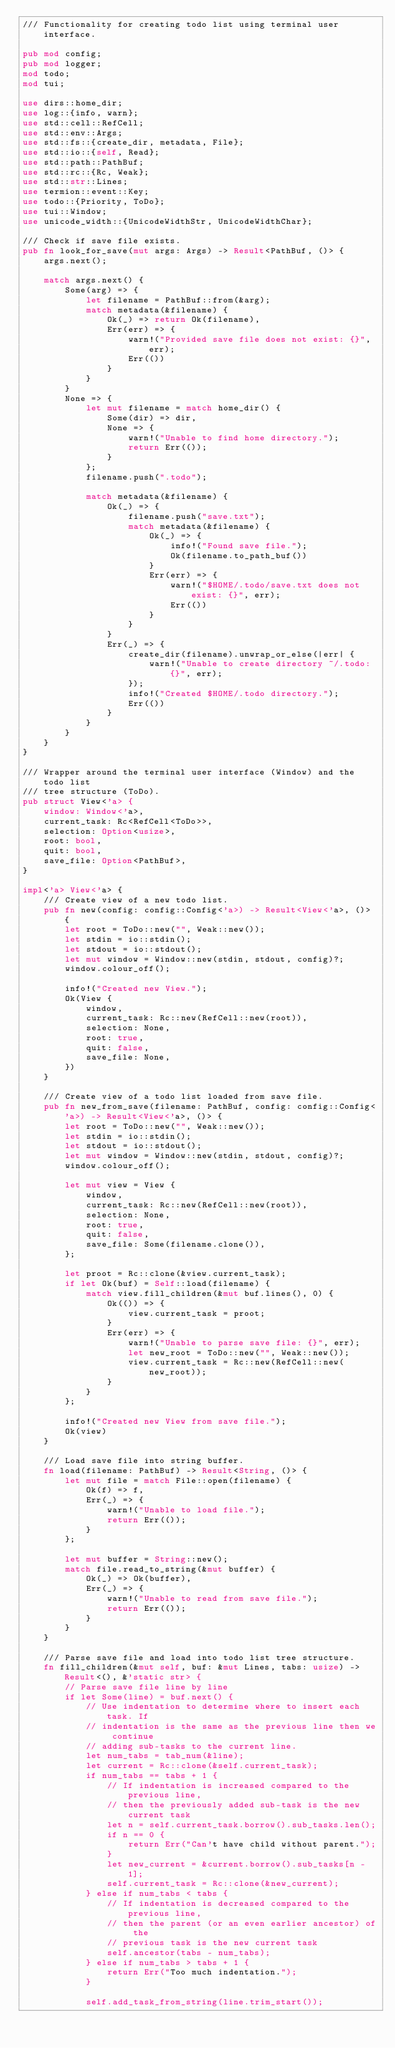Convert code to text. <code><loc_0><loc_0><loc_500><loc_500><_Rust_>/// Functionality for creating todo list using terminal user interface.

pub mod config;
pub mod logger;
mod todo;
mod tui;

use dirs::home_dir;
use log::{info, warn};
use std::cell::RefCell;
use std::env::Args;
use std::fs::{create_dir, metadata, File};
use std::io::{self, Read};
use std::path::PathBuf;
use std::rc::{Rc, Weak};
use std::str::Lines;
use termion::event::Key;
use todo::{Priority, ToDo};
use tui::Window;
use unicode_width::{UnicodeWidthStr, UnicodeWidthChar};

/// Check if save file exists.
pub fn look_for_save(mut args: Args) -> Result<PathBuf, ()> {
    args.next();

    match args.next() {
        Some(arg) => {
            let filename = PathBuf::from(&arg);
            match metadata(&filename) {
                Ok(_) => return Ok(filename),
                Err(err) => {
                    warn!("Provided save file does not exist: {}", err);
                    Err(())
                }
            }
        }
        None => {
            let mut filename = match home_dir() {
                Some(dir) => dir,
                None => {
                    warn!("Unable to find home directory.");
                    return Err(());
                }
            };
            filename.push(".todo");

            match metadata(&filename) {
                Ok(_) => {
                    filename.push("save.txt");
                    match metadata(&filename) {
                        Ok(_) => {
                            info!("Found save file.");
                            Ok(filename.to_path_buf())
                        }
                        Err(err) => {
                            warn!("$HOME/.todo/save.txt does not exist: {}", err);
                            Err(())
                        }
                    }
                }
                Err(_) => {
                    create_dir(filename).unwrap_or_else(|err| {
                        warn!("Unable to create directory ~/.todo: {}", err);
                    });
                    info!("Created $HOME/.todo directory.");
                    Err(())
                }
            }
        }
    }
}

/// Wrapper around the terminal user interface (Window) and the todo list
/// tree structure (ToDo).
pub struct View<'a> {
    window: Window<'a>,
    current_task: Rc<RefCell<ToDo>>,
    selection: Option<usize>,
    root: bool,
    quit: bool,
    save_file: Option<PathBuf>,
}

impl<'a> View<'a> {
    /// Create view of a new todo list.
    pub fn new(config: config::Config<'a>) -> Result<View<'a>, ()> {
        let root = ToDo::new("", Weak::new());
        let stdin = io::stdin();
        let stdout = io::stdout();
        let mut window = Window::new(stdin, stdout, config)?;
        window.colour_off();

        info!("Created new View.");
        Ok(View {
            window,
            current_task: Rc::new(RefCell::new(root)),
            selection: None,
            root: true,
            quit: false,
            save_file: None,
        })
    }

    /// Create view of a todo list loaded from save file.
    pub fn new_from_save(filename: PathBuf, config: config::Config<'a>) -> Result<View<'a>, ()> {
        let root = ToDo::new("", Weak::new());
        let stdin = io::stdin();
        let stdout = io::stdout();
        let mut window = Window::new(stdin, stdout, config)?;
        window.colour_off();

        let mut view = View {
            window,
            current_task: Rc::new(RefCell::new(root)),
            selection: None,
            root: true,
            quit: false,
            save_file: Some(filename.clone()),
        };

        let proot = Rc::clone(&view.current_task);
        if let Ok(buf) = Self::load(filename) {
            match view.fill_children(&mut buf.lines(), 0) {
                Ok(()) => {
                    view.current_task = proot;
                }
                Err(err) => {
                    warn!("Unable to parse save file: {}", err);
                    let new_root = ToDo::new("", Weak::new());
                    view.current_task = Rc::new(RefCell::new(new_root));
                }
            }
        };

        info!("Created new View from save file.");
        Ok(view)
    }

    /// Load save file into string buffer.
    fn load(filename: PathBuf) -> Result<String, ()> {
        let mut file = match File::open(filename) {
            Ok(f) => f,
            Err(_) => {
                warn!("Unable to load file.");
                return Err(());
            }
        };

        let mut buffer = String::new();
        match file.read_to_string(&mut buffer) {
            Ok(_) => Ok(buffer),
            Err(_) => {
                warn!("Unable to read from save file.");
                return Err(());
            }
        }
    }

    /// Parse save file and load into todo list tree structure.
    fn fill_children(&mut self, buf: &mut Lines, tabs: usize) -> Result<(), &'static str> {
        // Parse save file line by line
        if let Some(line) = buf.next() {
            // Use indentation to determine where to insert each task. If
            // indentation is the same as the previous line then we continue
            // adding sub-tasks to the current line.
            let num_tabs = tab_num(&line);
            let current = Rc::clone(&self.current_task);
            if num_tabs == tabs + 1 {
                // If indentation is increased compared to the previous line,
                // then the previously added sub-task is the new current task
                let n = self.current_task.borrow().sub_tasks.len();
                if n == 0 {
                    return Err("Can't have child without parent.");
                }
                let new_current = &current.borrow().sub_tasks[n - 1];
                self.current_task = Rc::clone(&new_current);
            } else if num_tabs < tabs {
                // If indentation is decreased compared to the previous line,
                // then the parent (or an even earlier ancestor) of the
                // previous task is the new current task
                self.ancestor(tabs - num_tabs);
            } else if num_tabs > tabs + 1 {
                return Err("Too much indentation.");
            }

            self.add_task_from_string(line.trim_start());
</code> 